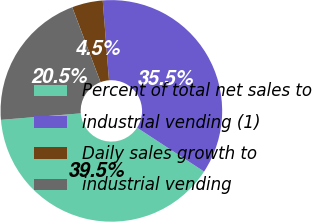<chart> <loc_0><loc_0><loc_500><loc_500><pie_chart><fcel>Percent of total net sales to<fcel>industrial vending (1)<fcel>Daily sales growth to<fcel>industrial vending<nl><fcel>39.49%<fcel>35.46%<fcel>4.5%<fcel>20.54%<nl></chart> 